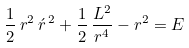Convert formula to latex. <formula><loc_0><loc_0><loc_500><loc_500>\frac { 1 } { 2 } \, r ^ { 2 } \, \acute { r } ^ { \, 2 } + \frac { 1 } { 2 } \, \frac { L ^ { 2 } } { r ^ { 4 } } - r ^ { 2 } = E</formula> 